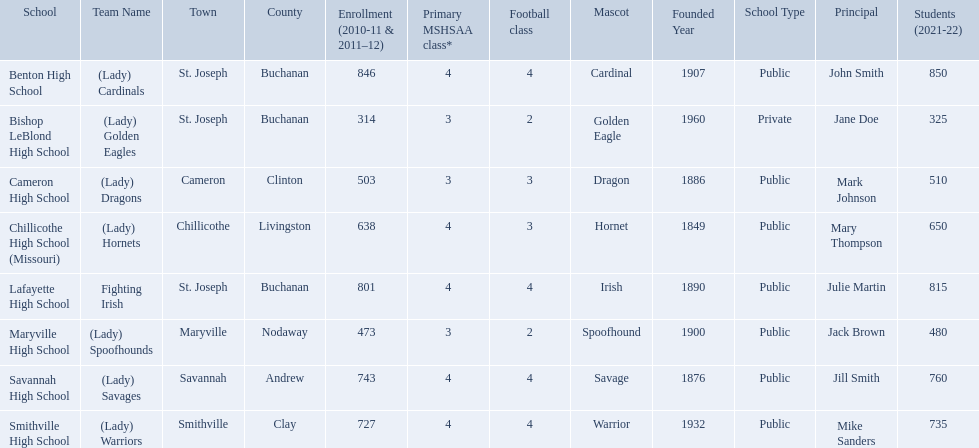What team uses green and grey as colors? Fighting Irish. What is this team called? Lafayette High School. What are all of the schools? Benton High School, Bishop LeBlond High School, Cameron High School, Chillicothe High School (Missouri), Lafayette High School, Maryville High School, Savannah High School, Smithville High School. How many football classes do they have? 4, 2, 3, 3, 4, 2, 4, 4. What about their enrollment? 846, 314, 503, 638, 801, 473, 743, 727. Which schools have 3 football classes? Cameron High School, Chillicothe High School (Missouri). And of those schools, which has 638 students? Chillicothe High School (Missouri). 